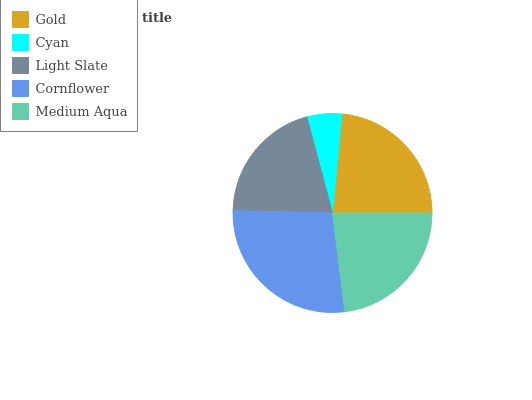Is Cyan the minimum?
Answer yes or no. Yes. Is Cornflower the maximum?
Answer yes or no. Yes. Is Light Slate the minimum?
Answer yes or no. No. Is Light Slate the maximum?
Answer yes or no. No. Is Light Slate greater than Cyan?
Answer yes or no. Yes. Is Cyan less than Light Slate?
Answer yes or no. Yes. Is Cyan greater than Light Slate?
Answer yes or no. No. Is Light Slate less than Cyan?
Answer yes or no. No. Is Medium Aqua the high median?
Answer yes or no. Yes. Is Medium Aqua the low median?
Answer yes or no. Yes. Is Light Slate the high median?
Answer yes or no. No. Is Gold the low median?
Answer yes or no. No. 